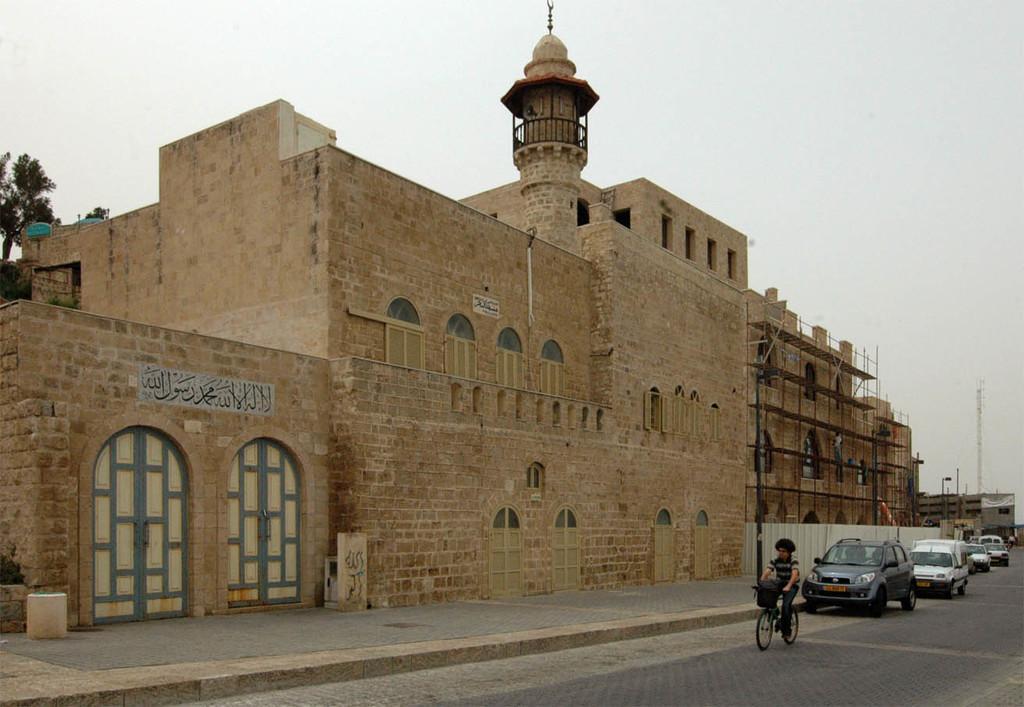In one or two sentences, can you explain what this image depicts? There are cars on the road and there is a person riding a bicycle. Here we can see buildings, boards, doors, poles, and trees. In the background we can see sky. 